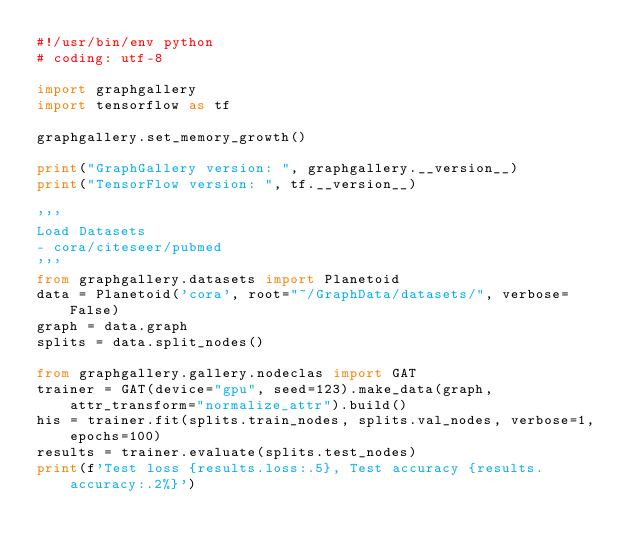<code> <loc_0><loc_0><loc_500><loc_500><_Python_>#!/usr/bin/env python
# coding: utf-8

import graphgallery
import tensorflow as tf

graphgallery.set_memory_growth()

print("GraphGallery version: ", graphgallery.__version__)
print("TensorFlow version: ", tf.__version__)

'''
Load Datasets
- cora/citeseer/pubmed
'''
from graphgallery.datasets import Planetoid
data = Planetoid('cora', root="~/GraphData/datasets/", verbose=False)
graph = data.graph
splits = data.split_nodes()

from graphgallery.gallery.nodeclas import GAT
trainer = GAT(device="gpu", seed=123).make_data(graph, attr_transform="normalize_attr").build()
his = trainer.fit(splits.train_nodes, splits.val_nodes, verbose=1, epochs=100)
results = trainer.evaluate(splits.test_nodes)
print(f'Test loss {results.loss:.5}, Test accuracy {results.accuracy:.2%}')
</code> 